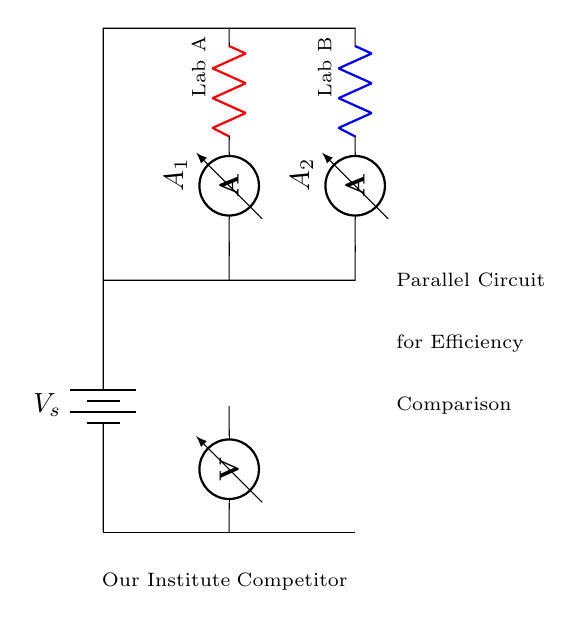What type of circuit is depicted? The circuit is a parallel circuit, as indicated by separate branches (Lab A and Lab B) that connect to the same two voltage terminals.
Answer: Parallel What are the components present in Lab A? Lab A has a resistor and an ammeter, which are the two main components shown for this branch.
Answer: Resistor, Ammeter What is the role of the ammeter in this circuit? The ammeter measures the current flowing through its respective branch, providing information on the performance of each lab.
Answer: Measure current What is the significance of the voltage across the two labs? In a parallel circuit, the voltage across each branch is the same, indicating that both labs experience the same supply voltage affecting their efficiency.
Answer: Same voltage Which lab has a higher likelihood of efficiency based on current measurement? The efficiency can be compared by examining the readings of the ammeters; the lab with higher current likely exhibits greater efficiency unless other factors are considered.
Answer: Depends on current readings How many branches does the circuit have? The circuit has two branches, each representing a different educational lab (Lab A and Lab B).
Answer: Two branches 